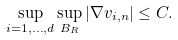<formula> <loc_0><loc_0><loc_500><loc_500>\sup _ { i = 1 , \dots , d } \sup _ { B _ { R } } | \nabla v _ { i , n } | \leq C .</formula> 